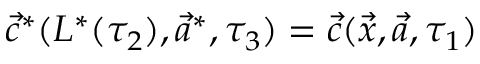Convert formula to latex. <formula><loc_0><loc_0><loc_500><loc_500>\vec { c } ^ { * } ( L ^ { * } ( \tau _ { 2 } ) , \vec { a } ^ { * } , \tau _ { 3 } ) = \vec { c } ( \vec { x } , \vec { a } , \tau _ { 1 } )</formula> 